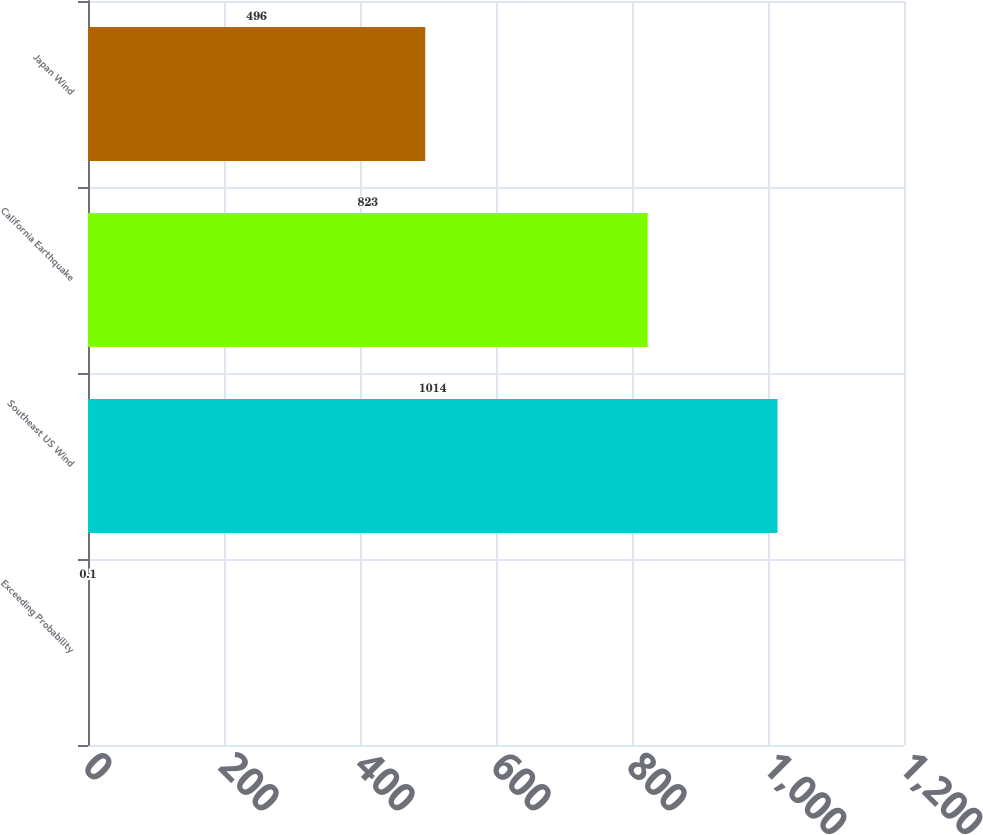<chart> <loc_0><loc_0><loc_500><loc_500><bar_chart><fcel>Exceeding Probability<fcel>Southeast US Wind<fcel>California Earthquake<fcel>Japan Wind<nl><fcel>0.1<fcel>1014<fcel>823<fcel>496<nl></chart> 